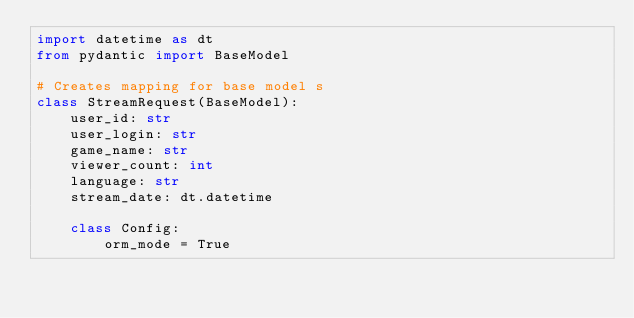Convert code to text. <code><loc_0><loc_0><loc_500><loc_500><_Python_>import datetime as dt
from pydantic import BaseModel

# Creates mapping for base model s
class StreamRequest(BaseModel):
    user_id: str
    user_login: str
    game_name: str
    viewer_count: int
    language: str
    stream_date: dt.datetime

    class Config:
        orm_mode = True
</code> 